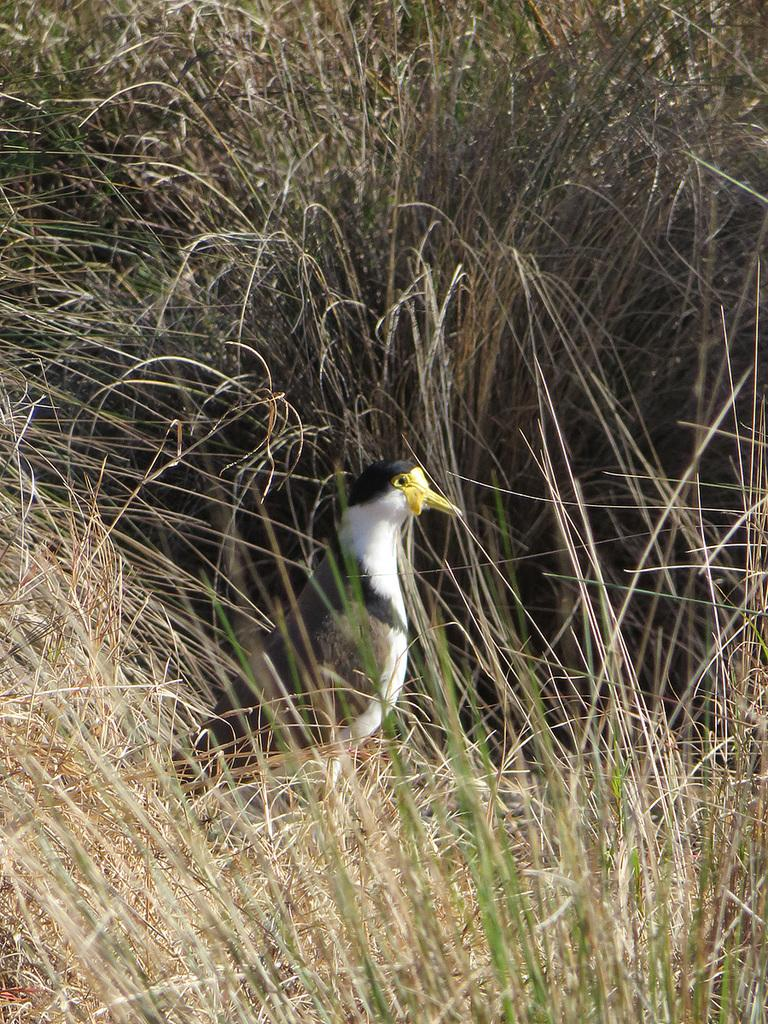What type of vegetation is visible in the image? There is grass in the image. What animal can be seen in the image? There is a bird in the middle of the image. How many houses are visible in the image? There are no houses present in the image; it features grass and a bird. What type of weapon is the bird holding in the image? There is no weapon, such as a quiver, present in the image, and the bird is not depicted as engaging in a fight. 